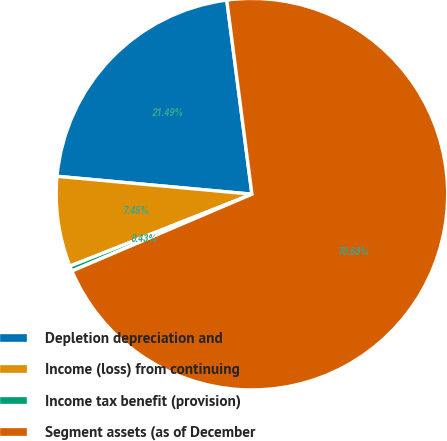Convert chart to OTSL. <chart><loc_0><loc_0><loc_500><loc_500><pie_chart><fcel>Depletion depreciation and<fcel>Income (loss) from continuing<fcel>Income tax benefit (provision)<fcel>Segment assets (as of December<nl><fcel>21.49%<fcel>7.45%<fcel>0.43%<fcel>70.63%<nl></chart> 